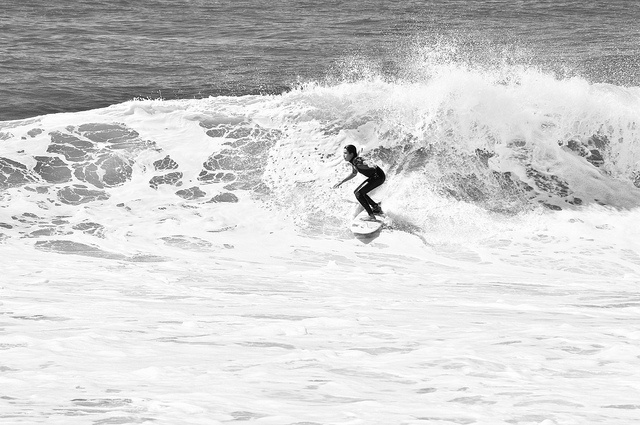Describe the objects in this image and their specific colors. I can see people in gray, black, darkgray, and lightgray tones and surfboard in gray, white, darkgray, and black tones in this image. 